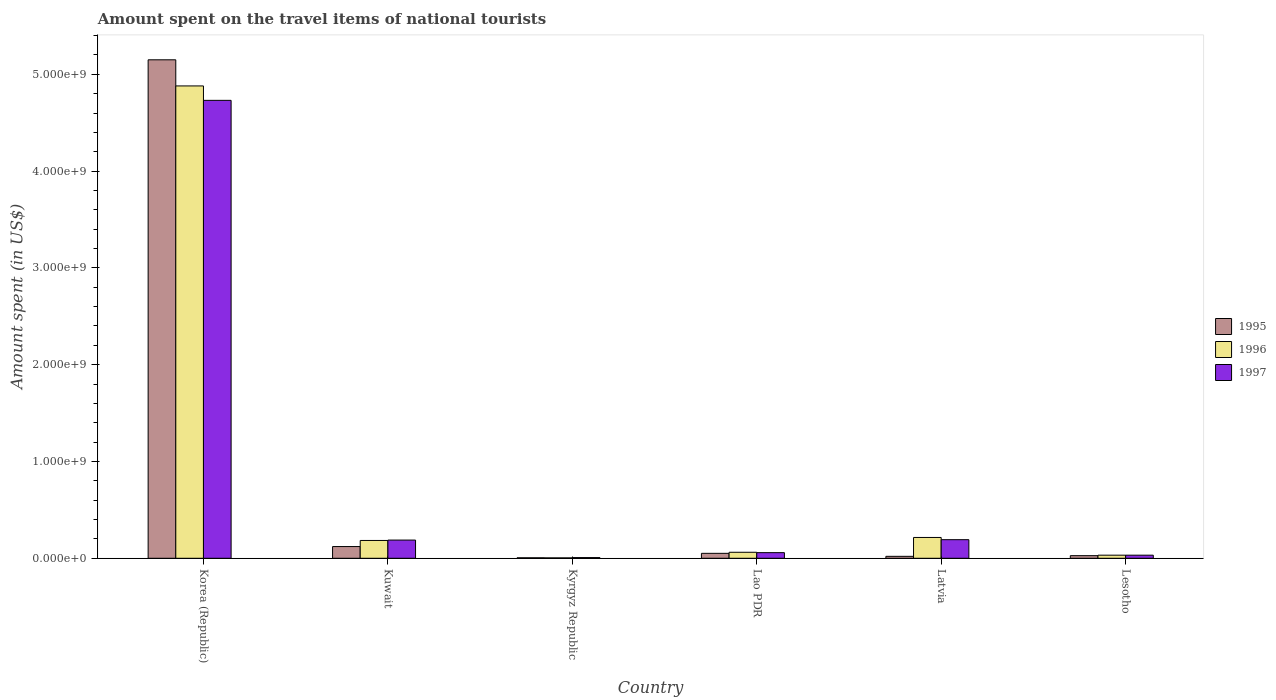How many different coloured bars are there?
Make the answer very short. 3. Are the number of bars per tick equal to the number of legend labels?
Provide a short and direct response. Yes. Are the number of bars on each tick of the X-axis equal?
Offer a very short reply. Yes. How many bars are there on the 1st tick from the left?
Keep it short and to the point. 3. What is the label of the 1st group of bars from the left?
Your answer should be very brief. Korea (Republic). What is the amount spent on the travel items of national tourists in 1997 in Latvia?
Make the answer very short. 1.92e+08. Across all countries, what is the maximum amount spent on the travel items of national tourists in 1997?
Give a very brief answer. 4.73e+09. Across all countries, what is the minimum amount spent on the travel items of national tourists in 1997?
Make the answer very short. 7.00e+06. In which country was the amount spent on the travel items of national tourists in 1996 minimum?
Provide a short and direct response. Kyrgyz Republic. What is the total amount spent on the travel items of national tourists in 1995 in the graph?
Ensure brevity in your answer.  5.37e+09. What is the difference between the amount spent on the travel items of national tourists in 1996 in Korea (Republic) and that in Latvia?
Offer a terse response. 4.66e+09. What is the difference between the amount spent on the travel items of national tourists in 1995 in Kyrgyz Republic and the amount spent on the travel items of national tourists in 1996 in Lesotho?
Provide a succinct answer. -2.70e+07. What is the average amount spent on the travel items of national tourists in 1995 per country?
Ensure brevity in your answer.  8.96e+08. What is the ratio of the amount spent on the travel items of national tourists in 1996 in Lao PDR to that in Lesotho?
Make the answer very short. 1.94. What is the difference between the highest and the second highest amount spent on the travel items of national tourists in 1995?
Keep it short and to the point. 5.03e+09. What is the difference between the highest and the lowest amount spent on the travel items of national tourists in 1996?
Ensure brevity in your answer.  4.88e+09. What does the 3rd bar from the left in Kuwait represents?
Ensure brevity in your answer.  1997. What does the 2nd bar from the right in Latvia represents?
Offer a very short reply. 1996. Is it the case that in every country, the sum of the amount spent on the travel items of national tourists in 1997 and amount spent on the travel items of national tourists in 1996 is greater than the amount spent on the travel items of national tourists in 1995?
Your answer should be very brief. Yes. Are all the bars in the graph horizontal?
Offer a very short reply. No. How many countries are there in the graph?
Offer a very short reply. 6. What is the difference between two consecutive major ticks on the Y-axis?
Offer a very short reply. 1.00e+09. Are the values on the major ticks of Y-axis written in scientific E-notation?
Your response must be concise. Yes. Where does the legend appear in the graph?
Ensure brevity in your answer.  Center right. How many legend labels are there?
Make the answer very short. 3. What is the title of the graph?
Offer a terse response. Amount spent on the travel items of national tourists. Does "1996" appear as one of the legend labels in the graph?
Offer a terse response. Yes. What is the label or title of the X-axis?
Your response must be concise. Country. What is the label or title of the Y-axis?
Your answer should be compact. Amount spent (in US$). What is the Amount spent (in US$) in 1995 in Korea (Republic)?
Ensure brevity in your answer.  5.15e+09. What is the Amount spent (in US$) in 1996 in Korea (Republic)?
Make the answer very short. 4.88e+09. What is the Amount spent (in US$) of 1997 in Korea (Republic)?
Your answer should be compact. 4.73e+09. What is the Amount spent (in US$) in 1995 in Kuwait?
Offer a terse response. 1.21e+08. What is the Amount spent (in US$) of 1996 in Kuwait?
Make the answer very short. 1.84e+08. What is the Amount spent (in US$) of 1997 in Kuwait?
Ensure brevity in your answer.  1.88e+08. What is the Amount spent (in US$) in 1995 in Kyrgyz Republic?
Provide a succinct answer. 5.00e+06. What is the Amount spent (in US$) in 1997 in Kyrgyz Republic?
Keep it short and to the point. 7.00e+06. What is the Amount spent (in US$) in 1995 in Lao PDR?
Make the answer very short. 5.10e+07. What is the Amount spent (in US$) in 1996 in Lao PDR?
Make the answer very short. 6.20e+07. What is the Amount spent (in US$) of 1997 in Lao PDR?
Make the answer very short. 5.80e+07. What is the Amount spent (in US$) in 1995 in Latvia?
Make the answer very short. 2.00e+07. What is the Amount spent (in US$) of 1996 in Latvia?
Your answer should be compact. 2.15e+08. What is the Amount spent (in US$) of 1997 in Latvia?
Your answer should be compact. 1.92e+08. What is the Amount spent (in US$) in 1995 in Lesotho?
Keep it short and to the point. 2.70e+07. What is the Amount spent (in US$) of 1996 in Lesotho?
Ensure brevity in your answer.  3.20e+07. What is the Amount spent (in US$) of 1997 in Lesotho?
Provide a succinct answer. 3.20e+07. Across all countries, what is the maximum Amount spent (in US$) in 1995?
Ensure brevity in your answer.  5.15e+09. Across all countries, what is the maximum Amount spent (in US$) of 1996?
Offer a very short reply. 4.88e+09. Across all countries, what is the maximum Amount spent (in US$) of 1997?
Ensure brevity in your answer.  4.73e+09. Across all countries, what is the minimum Amount spent (in US$) of 1997?
Provide a short and direct response. 7.00e+06. What is the total Amount spent (in US$) in 1995 in the graph?
Your response must be concise. 5.37e+09. What is the total Amount spent (in US$) in 1996 in the graph?
Provide a succinct answer. 5.38e+09. What is the total Amount spent (in US$) in 1997 in the graph?
Give a very brief answer. 5.21e+09. What is the difference between the Amount spent (in US$) of 1995 in Korea (Republic) and that in Kuwait?
Offer a terse response. 5.03e+09. What is the difference between the Amount spent (in US$) of 1996 in Korea (Republic) and that in Kuwait?
Your answer should be very brief. 4.70e+09. What is the difference between the Amount spent (in US$) in 1997 in Korea (Republic) and that in Kuwait?
Provide a short and direct response. 4.54e+09. What is the difference between the Amount spent (in US$) of 1995 in Korea (Republic) and that in Kyrgyz Republic?
Your answer should be compact. 5.14e+09. What is the difference between the Amount spent (in US$) in 1996 in Korea (Republic) and that in Kyrgyz Republic?
Offer a terse response. 4.88e+09. What is the difference between the Amount spent (in US$) of 1997 in Korea (Republic) and that in Kyrgyz Republic?
Ensure brevity in your answer.  4.72e+09. What is the difference between the Amount spent (in US$) in 1995 in Korea (Republic) and that in Lao PDR?
Provide a short and direct response. 5.10e+09. What is the difference between the Amount spent (in US$) of 1996 in Korea (Republic) and that in Lao PDR?
Your answer should be compact. 4.82e+09. What is the difference between the Amount spent (in US$) in 1997 in Korea (Republic) and that in Lao PDR?
Your answer should be compact. 4.67e+09. What is the difference between the Amount spent (in US$) of 1995 in Korea (Republic) and that in Latvia?
Ensure brevity in your answer.  5.13e+09. What is the difference between the Amount spent (in US$) of 1996 in Korea (Republic) and that in Latvia?
Offer a terse response. 4.66e+09. What is the difference between the Amount spent (in US$) of 1997 in Korea (Republic) and that in Latvia?
Make the answer very short. 4.54e+09. What is the difference between the Amount spent (in US$) in 1995 in Korea (Republic) and that in Lesotho?
Offer a terse response. 5.12e+09. What is the difference between the Amount spent (in US$) in 1996 in Korea (Republic) and that in Lesotho?
Your answer should be very brief. 4.85e+09. What is the difference between the Amount spent (in US$) in 1997 in Korea (Republic) and that in Lesotho?
Your response must be concise. 4.70e+09. What is the difference between the Amount spent (in US$) of 1995 in Kuwait and that in Kyrgyz Republic?
Give a very brief answer. 1.16e+08. What is the difference between the Amount spent (in US$) of 1996 in Kuwait and that in Kyrgyz Republic?
Provide a succinct answer. 1.80e+08. What is the difference between the Amount spent (in US$) of 1997 in Kuwait and that in Kyrgyz Republic?
Your answer should be very brief. 1.81e+08. What is the difference between the Amount spent (in US$) of 1995 in Kuwait and that in Lao PDR?
Keep it short and to the point. 7.00e+07. What is the difference between the Amount spent (in US$) of 1996 in Kuwait and that in Lao PDR?
Provide a short and direct response. 1.22e+08. What is the difference between the Amount spent (in US$) in 1997 in Kuwait and that in Lao PDR?
Offer a terse response. 1.30e+08. What is the difference between the Amount spent (in US$) in 1995 in Kuwait and that in Latvia?
Make the answer very short. 1.01e+08. What is the difference between the Amount spent (in US$) in 1996 in Kuwait and that in Latvia?
Give a very brief answer. -3.10e+07. What is the difference between the Amount spent (in US$) of 1995 in Kuwait and that in Lesotho?
Your answer should be compact. 9.40e+07. What is the difference between the Amount spent (in US$) in 1996 in Kuwait and that in Lesotho?
Ensure brevity in your answer.  1.52e+08. What is the difference between the Amount spent (in US$) of 1997 in Kuwait and that in Lesotho?
Offer a very short reply. 1.56e+08. What is the difference between the Amount spent (in US$) of 1995 in Kyrgyz Republic and that in Lao PDR?
Your answer should be compact. -4.60e+07. What is the difference between the Amount spent (in US$) of 1996 in Kyrgyz Republic and that in Lao PDR?
Make the answer very short. -5.80e+07. What is the difference between the Amount spent (in US$) in 1997 in Kyrgyz Republic and that in Lao PDR?
Give a very brief answer. -5.10e+07. What is the difference between the Amount spent (in US$) in 1995 in Kyrgyz Republic and that in Latvia?
Offer a terse response. -1.50e+07. What is the difference between the Amount spent (in US$) in 1996 in Kyrgyz Republic and that in Latvia?
Offer a terse response. -2.11e+08. What is the difference between the Amount spent (in US$) in 1997 in Kyrgyz Republic and that in Latvia?
Ensure brevity in your answer.  -1.85e+08. What is the difference between the Amount spent (in US$) of 1995 in Kyrgyz Republic and that in Lesotho?
Provide a short and direct response. -2.20e+07. What is the difference between the Amount spent (in US$) of 1996 in Kyrgyz Republic and that in Lesotho?
Provide a short and direct response. -2.80e+07. What is the difference between the Amount spent (in US$) in 1997 in Kyrgyz Republic and that in Lesotho?
Your answer should be very brief. -2.50e+07. What is the difference between the Amount spent (in US$) of 1995 in Lao PDR and that in Latvia?
Provide a succinct answer. 3.10e+07. What is the difference between the Amount spent (in US$) of 1996 in Lao PDR and that in Latvia?
Keep it short and to the point. -1.53e+08. What is the difference between the Amount spent (in US$) of 1997 in Lao PDR and that in Latvia?
Ensure brevity in your answer.  -1.34e+08. What is the difference between the Amount spent (in US$) in 1995 in Lao PDR and that in Lesotho?
Give a very brief answer. 2.40e+07. What is the difference between the Amount spent (in US$) of 1996 in Lao PDR and that in Lesotho?
Offer a very short reply. 3.00e+07. What is the difference between the Amount spent (in US$) in 1997 in Lao PDR and that in Lesotho?
Offer a terse response. 2.60e+07. What is the difference between the Amount spent (in US$) of 1995 in Latvia and that in Lesotho?
Ensure brevity in your answer.  -7.00e+06. What is the difference between the Amount spent (in US$) in 1996 in Latvia and that in Lesotho?
Your answer should be compact. 1.83e+08. What is the difference between the Amount spent (in US$) in 1997 in Latvia and that in Lesotho?
Offer a terse response. 1.60e+08. What is the difference between the Amount spent (in US$) of 1995 in Korea (Republic) and the Amount spent (in US$) of 1996 in Kuwait?
Offer a terse response. 4.97e+09. What is the difference between the Amount spent (in US$) in 1995 in Korea (Republic) and the Amount spent (in US$) in 1997 in Kuwait?
Offer a very short reply. 4.96e+09. What is the difference between the Amount spent (in US$) of 1996 in Korea (Republic) and the Amount spent (in US$) of 1997 in Kuwait?
Keep it short and to the point. 4.69e+09. What is the difference between the Amount spent (in US$) in 1995 in Korea (Republic) and the Amount spent (in US$) in 1996 in Kyrgyz Republic?
Make the answer very short. 5.15e+09. What is the difference between the Amount spent (in US$) of 1995 in Korea (Republic) and the Amount spent (in US$) of 1997 in Kyrgyz Republic?
Provide a short and direct response. 5.14e+09. What is the difference between the Amount spent (in US$) of 1996 in Korea (Republic) and the Amount spent (in US$) of 1997 in Kyrgyz Republic?
Ensure brevity in your answer.  4.87e+09. What is the difference between the Amount spent (in US$) of 1995 in Korea (Republic) and the Amount spent (in US$) of 1996 in Lao PDR?
Give a very brief answer. 5.09e+09. What is the difference between the Amount spent (in US$) of 1995 in Korea (Republic) and the Amount spent (in US$) of 1997 in Lao PDR?
Give a very brief answer. 5.09e+09. What is the difference between the Amount spent (in US$) in 1996 in Korea (Republic) and the Amount spent (in US$) in 1997 in Lao PDR?
Your response must be concise. 4.82e+09. What is the difference between the Amount spent (in US$) of 1995 in Korea (Republic) and the Amount spent (in US$) of 1996 in Latvia?
Your answer should be compact. 4.94e+09. What is the difference between the Amount spent (in US$) of 1995 in Korea (Republic) and the Amount spent (in US$) of 1997 in Latvia?
Provide a succinct answer. 4.96e+09. What is the difference between the Amount spent (in US$) in 1996 in Korea (Republic) and the Amount spent (in US$) in 1997 in Latvia?
Your response must be concise. 4.69e+09. What is the difference between the Amount spent (in US$) of 1995 in Korea (Republic) and the Amount spent (in US$) of 1996 in Lesotho?
Ensure brevity in your answer.  5.12e+09. What is the difference between the Amount spent (in US$) in 1995 in Korea (Republic) and the Amount spent (in US$) in 1997 in Lesotho?
Provide a short and direct response. 5.12e+09. What is the difference between the Amount spent (in US$) of 1996 in Korea (Republic) and the Amount spent (in US$) of 1997 in Lesotho?
Offer a very short reply. 4.85e+09. What is the difference between the Amount spent (in US$) of 1995 in Kuwait and the Amount spent (in US$) of 1996 in Kyrgyz Republic?
Your answer should be compact. 1.17e+08. What is the difference between the Amount spent (in US$) of 1995 in Kuwait and the Amount spent (in US$) of 1997 in Kyrgyz Republic?
Your answer should be compact. 1.14e+08. What is the difference between the Amount spent (in US$) in 1996 in Kuwait and the Amount spent (in US$) in 1997 in Kyrgyz Republic?
Provide a succinct answer. 1.77e+08. What is the difference between the Amount spent (in US$) of 1995 in Kuwait and the Amount spent (in US$) of 1996 in Lao PDR?
Ensure brevity in your answer.  5.90e+07. What is the difference between the Amount spent (in US$) of 1995 in Kuwait and the Amount spent (in US$) of 1997 in Lao PDR?
Keep it short and to the point. 6.30e+07. What is the difference between the Amount spent (in US$) of 1996 in Kuwait and the Amount spent (in US$) of 1997 in Lao PDR?
Give a very brief answer. 1.26e+08. What is the difference between the Amount spent (in US$) of 1995 in Kuwait and the Amount spent (in US$) of 1996 in Latvia?
Provide a short and direct response. -9.40e+07. What is the difference between the Amount spent (in US$) of 1995 in Kuwait and the Amount spent (in US$) of 1997 in Latvia?
Give a very brief answer. -7.10e+07. What is the difference between the Amount spent (in US$) in 1996 in Kuwait and the Amount spent (in US$) in 1997 in Latvia?
Offer a very short reply. -8.00e+06. What is the difference between the Amount spent (in US$) in 1995 in Kuwait and the Amount spent (in US$) in 1996 in Lesotho?
Your answer should be very brief. 8.90e+07. What is the difference between the Amount spent (in US$) in 1995 in Kuwait and the Amount spent (in US$) in 1997 in Lesotho?
Ensure brevity in your answer.  8.90e+07. What is the difference between the Amount spent (in US$) in 1996 in Kuwait and the Amount spent (in US$) in 1997 in Lesotho?
Keep it short and to the point. 1.52e+08. What is the difference between the Amount spent (in US$) of 1995 in Kyrgyz Republic and the Amount spent (in US$) of 1996 in Lao PDR?
Provide a short and direct response. -5.70e+07. What is the difference between the Amount spent (in US$) in 1995 in Kyrgyz Republic and the Amount spent (in US$) in 1997 in Lao PDR?
Your response must be concise. -5.30e+07. What is the difference between the Amount spent (in US$) in 1996 in Kyrgyz Republic and the Amount spent (in US$) in 1997 in Lao PDR?
Provide a short and direct response. -5.40e+07. What is the difference between the Amount spent (in US$) of 1995 in Kyrgyz Republic and the Amount spent (in US$) of 1996 in Latvia?
Your answer should be very brief. -2.10e+08. What is the difference between the Amount spent (in US$) in 1995 in Kyrgyz Republic and the Amount spent (in US$) in 1997 in Latvia?
Provide a succinct answer. -1.87e+08. What is the difference between the Amount spent (in US$) of 1996 in Kyrgyz Republic and the Amount spent (in US$) of 1997 in Latvia?
Your answer should be very brief. -1.88e+08. What is the difference between the Amount spent (in US$) of 1995 in Kyrgyz Republic and the Amount spent (in US$) of 1996 in Lesotho?
Your answer should be very brief. -2.70e+07. What is the difference between the Amount spent (in US$) of 1995 in Kyrgyz Republic and the Amount spent (in US$) of 1997 in Lesotho?
Your answer should be very brief. -2.70e+07. What is the difference between the Amount spent (in US$) of 1996 in Kyrgyz Republic and the Amount spent (in US$) of 1997 in Lesotho?
Make the answer very short. -2.80e+07. What is the difference between the Amount spent (in US$) of 1995 in Lao PDR and the Amount spent (in US$) of 1996 in Latvia?
Provide a short and direct response. -1.64e+08. What is the difference between the Amount spent (in US$) of 1995 in Lao PDR and the Amount spent (in US$) of 1997 in Latvia?
Make the answer very short. -1.41e+08. What is the difference between the Amount spent (in US$) of 1996 in Lao PDR and the Amount spent (in US$) of 1997 in Latvia?
Your answer should be compact. -1.30e+08. What is the difference between the Amount spent (in US$) of 1995 in Lao PDR and the Amount spent (in US$) of 1996 in Lesotho?
Your answer should be compact. 1.90e+07. What is the difference between the Amount spent (in US$) of 1995 in Lao PDR and the Amount spent (in US$) of 1997 in Lesotho?
Offer a very short reply. 1.90e+07. What is the difference between the Amount spent (in US$) in 1996 in Lao PDR and the Amount spent (in US$) in 1997 in Lesotho?
Your answer should be compact. 3.00e+07. What is the difference between the Amount spent (in US$) of 1995 in Latvia and the Amount spent (in US$) of 1996 in Lesotho?
Provide a short and direct response. -1.20e+07. What is the difference between the Amount spent (in US$) in 1995 in Latvia and the Amount spent (in US$) in 1997 in Lesotho?
Offer a terse response. -1.20e+07. What is the difference between the Amount spent (in US$) of 1996 in Latvia and the Amount spent (in US$) of 1997 in Lesotho?
Make the answer very short. 1.83e+08. What is the average Amount spent (in US$) of 1995 per country?
Make the answer very short. 8.96e+08. What is the average Amount spent (in US$) in 1996 per country?
Provide a succinct answer. 8.96e+08. What is the average Amount spent (in US$) in 1997 per country?
Your response must be concise. 8.68e+08. What is the difference between the Amount spent (in US$) in 1995 and Amount spent (in US$) in 1996 in Korea (Republic)?
Offer a very short reply. 2.70e+08. What is the difference between the Amount spent (in US$) in 1995 and Amount spent (in US$) in 1997 in Korea (Republic)?
Offer a very short reply. 4.19e+08. What is the difference between the Amount spent (in US$) of 1996 and Amount spent (in US$) of 1997 in Korea (Republic)?
Your response must be concise. 1.49e+08. What is the difference between the Amount spent (in US$) of 1995 and Amount spent (in US$) of 1996 in Kuwait?
Your answer should be very brief. -6.30e+07. What is the difference between the Amount spent (in US$) of 1995 and Amount spent (in US$) of 1997 in Kuwait?
Offer a terse response. -6.70e+07. What is the difference between the Amount spent (in US$) in 1996 and Amount spent (in US$) in 1997 in Kuwait?
Keep it short and to the point. -4.00e+06. What is the difference between the Amount spent (in US$) of 1995 and Amount spent (in US$) of 1997 in Kyrgyz Republic?
Give a very brief answer. -2.00e+06. What is the difference between the Amount spent (in US$) in 1995 and Amount spent (in US$) in 1996 in Lao PDR?
Your answer should be very brief. -1.10e+07. What is the difference between the Amount spent (in US$) in 1995 and Amount spent (in US$) in 1997 in Lao PDR?
Provide a short and direct response. -7.00e+06. What is the difference between the Amount spent (in US$) in 1995 and Amount spent (in US$) in 1996 in Latvia?
Give a very brief answer. -1.95e+08. What is the difference between the Amount spent (in US$) of 1995 and Amount spent (in US$) of 1997 in Latvia?
Your answer should be very brief. -1.72e+08. What is the difference between the Amount spent (in US$) of 1996 and Amount spent (in US$) of 1997 in Latvia?
Your answer should be compact. 2.30e+07. What is the difference between the Amount spent (in US$) of 1995 and Amount spent (in US$) of 1996 in Lesotho?
Your answer should be compact. -5.00e+06. What is the difference between the Amount spent (in US$) of 1995 and Amount spent (in US$) of 1997 in Lesotho?
Keep it short and to the point. -5.00e+06. What is the ratio of the Amount spent (in US$) in 1995 in Korea (Republic) to that in Kuwait?
Your response must be concise. 42.56. What is the ratio of the Amount spent (in US$) of 1996 in Korea (Republic) to that in Kuwait?
Offer a terse response. 26.52. What is the ratio of the Amount spent (in US$) in 1997 in Korea (Republic) to that in Kuwait?
Keep it short and to the point. 25.16. What is the ratio of the Amount spent (in US$) of 1995 in Korea (Republic) to that in Kyrgyz Republic?
Provide a succinct answer. 1030. What is the ratio of the Amount spent (in US$) in 1996 in Korea (Republic) to that in Kyrgyz Republic?
Your answer should be very brief. 1220. What is the ratio of the Amount spent (in US$) of 1997 in Korea (Republic) to that in Kyrgyz Republic?
Offer a terse response. 675.86. What is the ratio of the Amount spent (in US$) in 1995 in Korea (Republic) to that in Lao PDR?
Keep it short and to the point. 100.98. What is the ratio of the Amount spent (in US$) of 1996 in Korea (Republic) to that in Lao PDR?
Your answer should be compact. 78.71. What is the ratio of the Amount spent (in US$) in 1997 in Korea (Republic) to that in Lao PDR?
Provide a short and direct response. 81.57. What is the ratio of the Amount spent (in US$) of 1995 in Korea (Republic) to that in Latvia?
Ensure brevity in your answer.  257.5. What is the ratio of the Amount spent (in US$) of 1996 in Korea (Republic) to that in Latvia?
Provide a short and direct response. 22.7. What is the ratio of the Amount spent (in US$) of 1997 in Korea (Republic) to that in Latvia?
Your answer should be compact. 24.64. What is the ratio of the Amount spent (in US$) in 1995 in Korea (Republic) to that in Lesotho?
Make the answer very short. 190.74. What is the ratio of the Amount spent (in US$) of 1996 in Korea (Republic) to that in Lesotho?
Your answer should be very brief. 152.5. What is the ratio of the Amount spent (in US$) in 1997 in Korea (Republic) to that in Lesotho?
Your answer should be compact. 147.84. What is the ratio of the Amount spent (in US$) of 1995 in Kuwait to that in Kyrgyz Republic?
Ensure brevity in your answer.  24.2. What is the ratio of the Amount spent (in US$) of 1997 in Kuwait to that in Kyrgyz Republic?
Provide a succinct answer. 26.86. What is the ratio of the Amount spent (in US$) in 1995 in Kuwait to that in Lao PDR?
Your answer should be compact. 2.37. What is the ratio of the Amount spent (in US$) in 1996 in Kuwait to that in Lao PDR?
Make the answer very short. 2.97. What is the ratio of the Amount spent (in US$) of 1997 in Kuwait to that in Lao PDR?
Provide a short and direct response. 3.24. What is the ratio of the Amount spent (in US$) of 1995 in Kuwait to that in Latvia?
Give a very brief answer. 6.05. What is the ratio of the Amount spent (in US$) in 1996 in Kuwait to that in Latvia?
Make the answer very short. 0.86. What is the ratio of the Amount spent (in US$) in 1997 in Kuwait to that in Latvia?
Provide a succinct answer. 0.98. What is the ratio of the Amount spent (in US$) in 1995 in Kuwait to that in Lesotho?
Offer a terse response. 4.48. What is the ratio of the Amount spent (in US$) of 1996 in Kuwait to that in Lesotho?
Ensure brevity in your answer.  5.75. What is the ratio of the Amount spent (in US$) in 1997 in Kuwait to that in Lesotho?
Keep it short and to the point. 5.88. What is the ratio of the Amount spent (in US$) of 1995 in Kyrgyz Republic to that in Lao PDR?
Your answer should be compact. 0.1. What is the ratio of the Amount spent (in US$) in 1996 in Kyrgyz Republic to that in Lao PDR?
Make the answer very short. 0.06. What is the ratio of the Amount spent (in US$) in 1997 in Kyrgyz Republic to that in Lao PDR?
Your answer should be very brief. 0.12. What is the ratio of the Amount spent (in US$) of 1995 in Kyrgyz Republic to that in Latvia?
Offer a very short reply. 0.25. What is the ratio of the Amount spent (in US$) in 1996 in Kyrgyz Republic to that in Latvia?
Your answer should be compact. 0.02. What is the ratio of the Amount spent (in US$) of 1997 in Kyrgyz Republic to that in Latvia?
Offer a terse response. 0.04. What is the ratio of the Amount spent (in US$) in 1995 in Kyrgyz Republic to that in Lesotho?
Your answer should be very brief. 0.19. What is the ratio of the Amount spent (in US$) of 1996 in Kyrgyz Republic to that in Lesotho?
Your response must be concise. 0.12. What is the ratio of the Amount spent (in US$) of 1997 in Kyrgyz Republic to that in Lesotho?
Your response must be concise. 0.22. What is the ratio of the Amount spent (in US$) in 1995 in Lao PDR to that in Latvia?
Give a very brief answer. 2.55. What is the ratio of the Amount spent (in US$) in 1996 in Lao PDR to that in Latvia?
Provide a short and direct response. 0.29. What is the ratio of the Amount spent (in US$) in 1997 in Lao PDR to that in Latvia?
Your response must be concise. 0.3. What is the ratio of the Amount spent (in US$) of 1995 in Lao PDR to that in Lesotho?
Your response must be concise. 1.89. What is the ratio of the Amount spent (in US$) of 1996 in Lao PDR to that in Lesotho?
Offer a very short reply. 1.94. What is the ratio of the Amount spent (in US$) of 1997 in Lao PDR to that in Lesotho?
Make the answer very short. 1.81. What is the ratio of the Amount spent (in US$) of 1995 in Latvia to that in Lesotho?
Provide a short and direct response. 0.74. What is the ratio of the Amount spent (in US$) of 1996 in Latvia to that in Lesotho?
Provide a succinct answer. 6.72. What is the difference between the highest and the second highest Amount spent (in US$) of 1995?
Make the answer very short. 5.03e+09. What is the difference between the highest and the second highest Amount spent (in US$) in 1996?
Provide a succinct answer. 4.66e+09. What is the difference between the highest and the second highest Amount spent (in US$) in 1997?
Ensure brevity in your answer.  4.54e+09. What is the difference between the highest and the lowest Amount spent (in US$) in 1995?
Provide a short and direct response. 5.14e+09. What is the difference between the highest and the lowest Amount spent (in US$) in 1996?
Your response must be concise. 4.88e+09. What is the difference between the highest and the lowest Amount spent (in US$) of 1997?
Your response must be concise. 4.72e+09. 